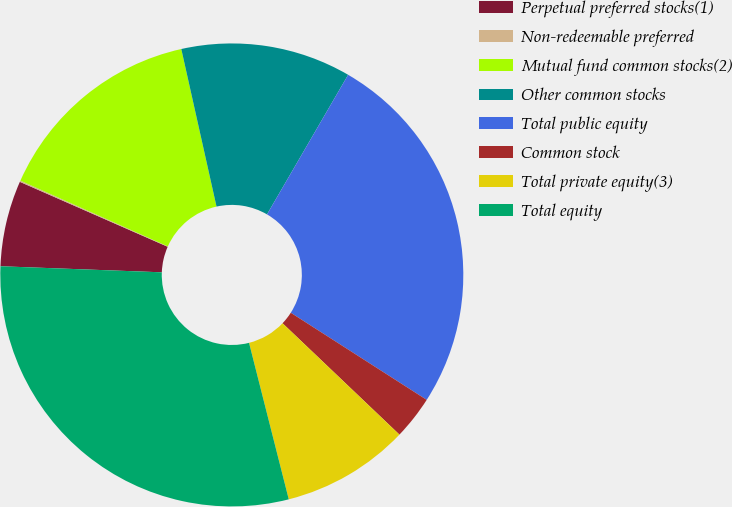Convert chart to OTSL. <chart><loc_0><loc_0><loc_500><loc_500><pie_chart><fcel>Perpetual preferred stocks(1)<fcel>Non-redeemable preferred<fcel>Mutual fund common stocks(2)<fcel>Other common stocks<fcel>Total public equity<fcel>Common stock<fcel>Total private equity(3)<fcel>Total equity<nl><fcel>5.99%<fcel>0.09%<fcel>14.82%<fcel>11.88%<fcel>25.69%<fcel>3.04%<fcel>8.93%<fcel>29.55%<nl></chart> 